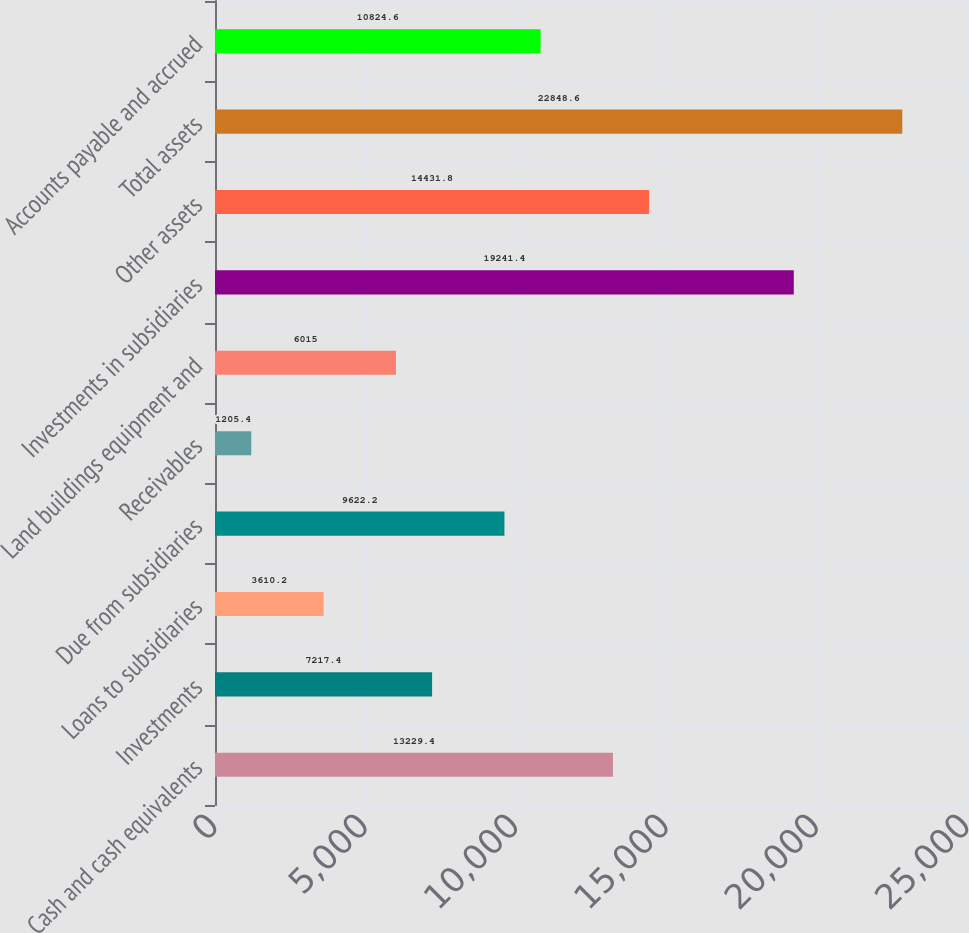Convert chart. <chart><loc_0><loc_0><loc_500><loc_500><bar_chart><fcel>Cash and cash equivalents<fcel>Investments<fcel>Loans to subsidiaries<fcel>Due from subsidiaries<fcel>Receivables<fcel>Land buildings equipment and<fcel>Investments in subsidiaries<fcel>Other assets<fcel>Total assets<fcel>Accounts payable and accrued<nl><fcel>13229.4<fcel>7217.4<fcel>3610.2<fcel>9622.2<fcel>1205.4<fcel>6015<fcel>19241.4<fcel>14431.8<fcel>22848.6<fcel>10824.6<nl></chart> 